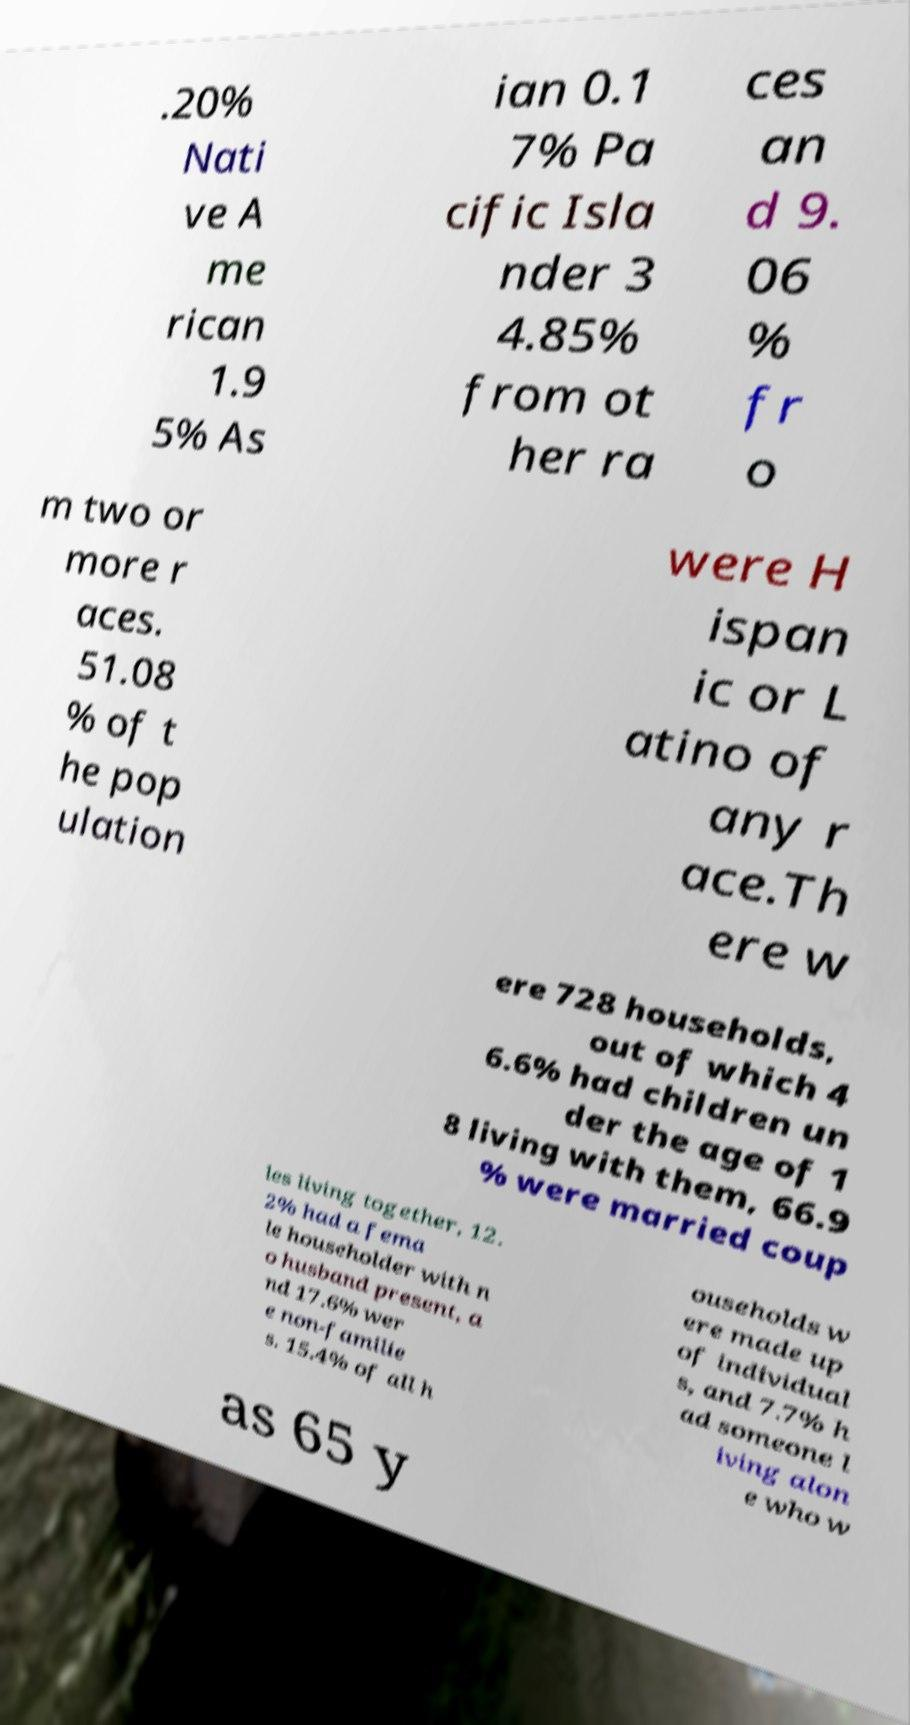I need the written content from this picture converted into text. Can you do that? .20% Nati ve A me rican 1.9 5% As ian 0.1 7% Pa cific Isla nder 3 4.85% from ot her ra ces an d 9. 06 % fr o m two or more r aces. 51.08 % of t he pop ulation were H ispan ic or L atino of any r ace.Th ere w ere 728 households, out of which 4 6.6% had children un der the age of 1 8 living with them, 66.9 % were married coup les living together, 12. 2% had a fema le householder with n o husband present, a nd 17.6% wer e non-familie s. 15.4% of all h ouseholds w ere made up of individual s, and 7.7% h ad someone l iving alon e who w as 65 y 